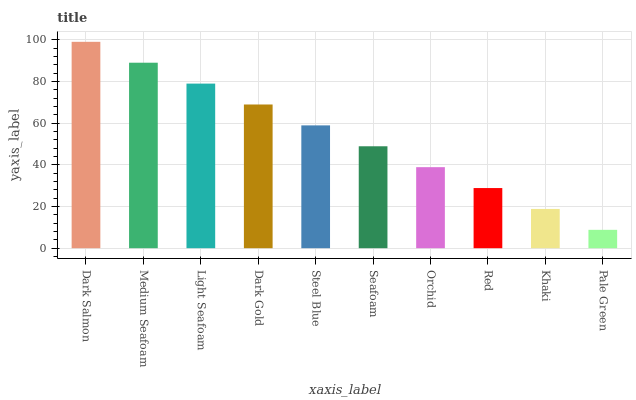Is Pale Green the minimum?
Answer yes or no. Yes. Is Dark Salmon the maximum?
Answer yes or no. Yes. Is Medium Seafoam the minimum?
Answer yes or no. No. Is Medium Seafoam the maximum?
Answer yes or no. No. Is Dark Salmon greater than Medium Seafoam?
Answer yes or no. Yes. Is Medium Seafoam less than Dark Salmon?
Answer yes or no. Yes. Is Medium Seafoam greater than Dark Salmon?
Answer yes or no. No. Is Dark Salmon less than Medium Seafoam?
Answer yes or no. No. Is Steel Blue the high median?
Answer yes or no. Yes. Is Seafoam the low median?
Answer yes or no. Yes. Is Khaki the high median?
Answer yes or no. No. Is Khaki the low median?
Answer yes or no. No. 